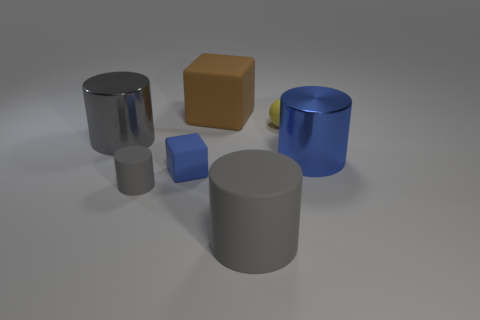Do the shiny cylinder in front of the gray shiny thing and the tiny gray rubber object have the same size?
Your answer should be very brief. No. What color is the small rubber object that is the same shape as the big brown rubber object?
Provide a short and direct response. Blue. What is the shape of the big shiny thing left of the small object behind the big metal object that is on the left side of the small rubber sphere?
Provide a short and direct response. Cylinder. Do the blue metal object and the brown object have the same shape?
Ensure brevity in your answer.  No. What is the shape of the blue thing to the left of the tiny ball to the right of the big brown rubber object?
Offer a terse response. Cube. Is there a yellow object?
Keep it short and to the point. Yes. What number of brown objects are right of the matte block that is in front of the metallic cylinder left of the yellow matte ball?
Keep it short and to the point. 1. There is a blue metal object; does it have the same shape as the rubber object in front of the small gray cylinder?
Your answer should be very brief. Yes. Are there more large rubber things than big brown things?
Provide a succinct answer. Yes. There is a big gray object on the right side of the large block; is it the same shape as the large blue metallic thing?
Your response must be concise. Yes. 